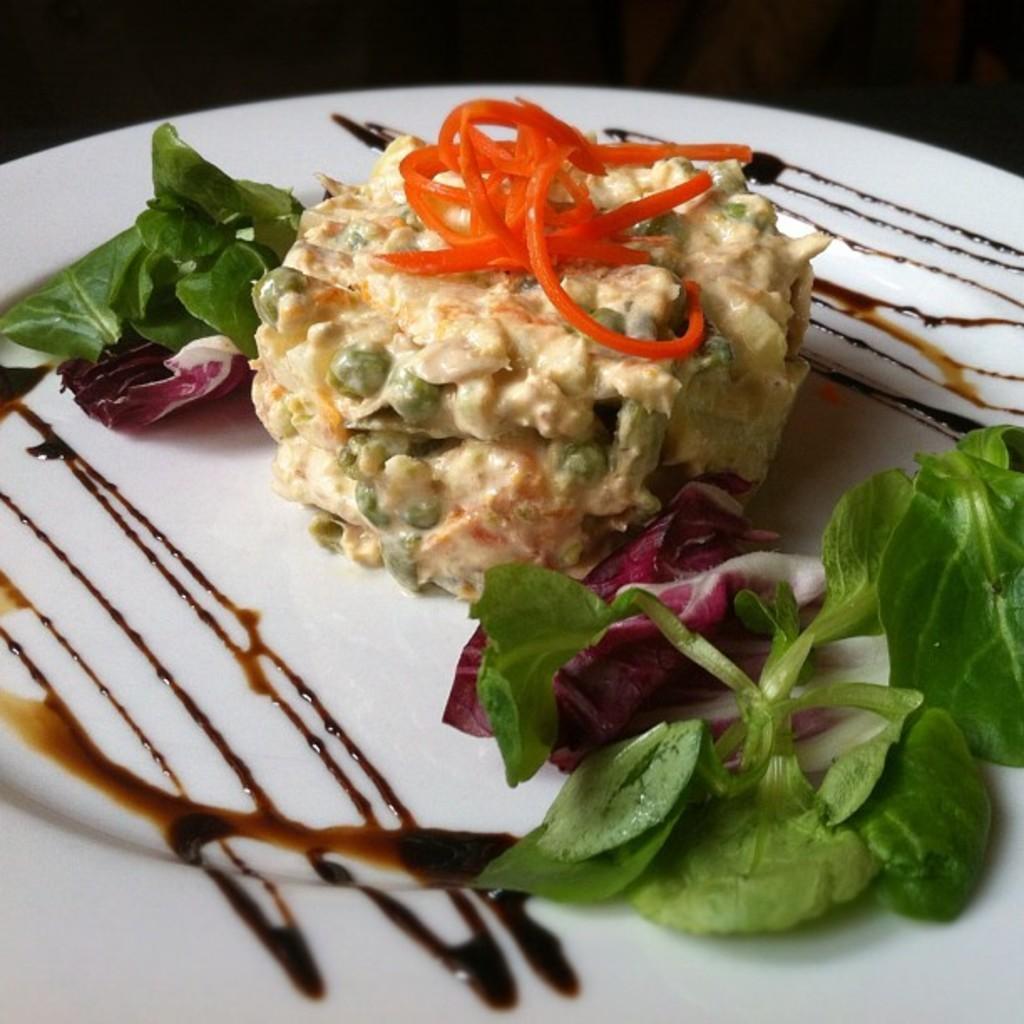How would you summarize this image in a sentence or two? In this image we can see a food item is kept on the white color plate. The background of the image is dark. 